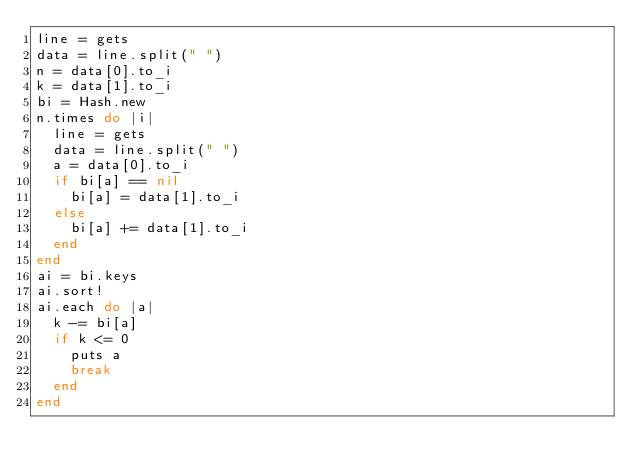<code> <loc_0><loc_0><loc_500><loc_500><_Ruby_>line = gets
data = line.split(" ")
n = data[0].to_i
k = data[1].to_i
bi = Hash.new
n.times do |i|
  line = gets
  data = line.split(" ")
  a = data[0].to_i
  if bi[a] == nil
    bi[a] = data[1].to_i
  else
    bi[a] += data[1].to_i
  end
end
ai = bi.keys
ai.sort!
ai.each do |a|
  k -= bi[a]
  if k <= 0
    puts a
    break
  end
end</code> 